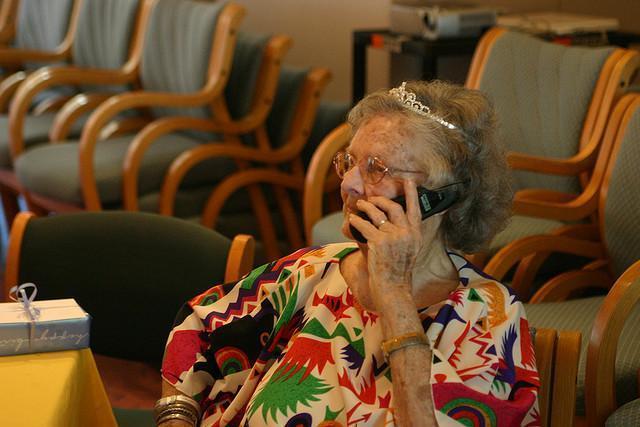How many chairs are there?
Give a very brief answer. 10. How many blue boats are in the picture?
Give a very brief answer. 0. 